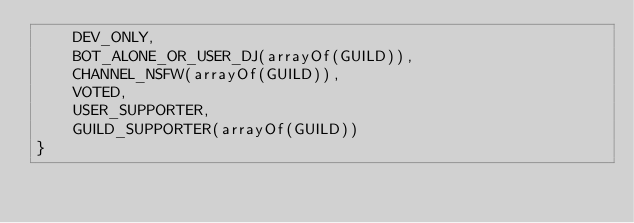Convert code to text. <code><loc_0><loc_0><loc_500><loc_500><_Kotlin_>    DEV_ONLY,
    BOT_ALONE_OR_USER_DJ(arrayOf(GUILD)),
    CHANNEL_NSFW(arrayOf(GUILD)),
    VOTED,
    USER_SUPPORTER,
    GUILD_SUPPORTER(arrayOf(GUILD))
}</code> 